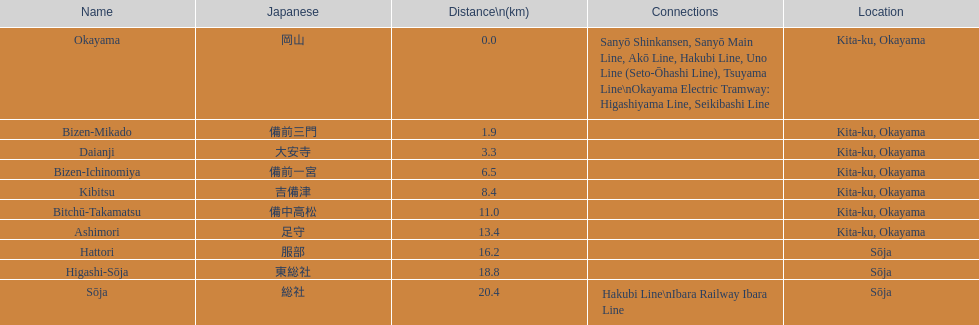Between hattori and kibitsu, which one is more distant? Hattori. 